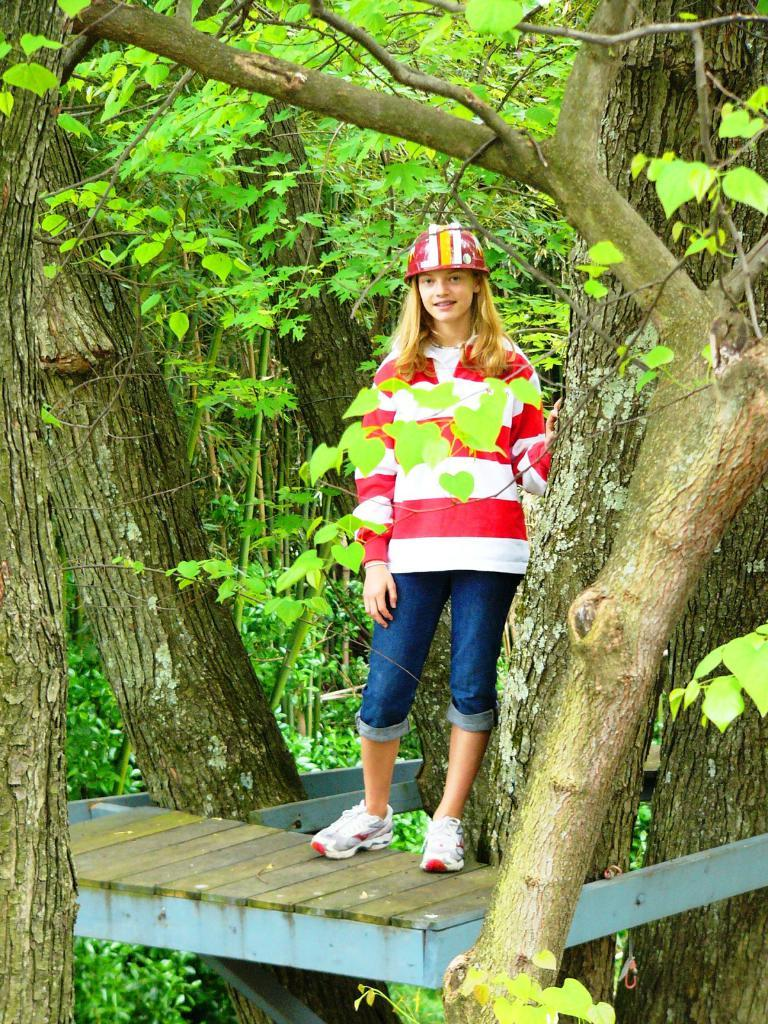Who is the main subject in the image? There is a lady in the image. What is the lady doing in the image? The lady is standing on a wooden bench. What can be seen in the background of the image? There are trees in the background of the image. What type of bedroom can be seen in the image? There is no bedroom present in the image; it features a lady standing on a wooden bench with trees in the background. 